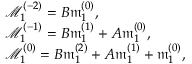<formula> <loc_0><loc_0><loc_500><loc_500>\begin{array} { r l } & { \mathcal { M } _ { 1 } ^ { ( - 2 ) } = B \mathfrak { m } _ { 1 } ^ { ( 0 ) } , } \\ & { \mathcal { M } _ { 1 } ^ { ( - 1 ) } = B \mathfrak { m } _ { 1 } ^ { ( 1 ) } + A \mathfrak { m } _ { 1 } ^ { ( 0 ) } , } \\ & { \mathcal { M } _ { 1 } ^ { ( 0 ) } = B \mathfrak { m } _ { 1 } ^ { ( 2 ) } + A \mathfrak { m } _ { 1 } ^ { ( 1 ) } + \mathfrak { m } _ { 1 } ^ { ( 0 ) } , } \end{array}</formula> 